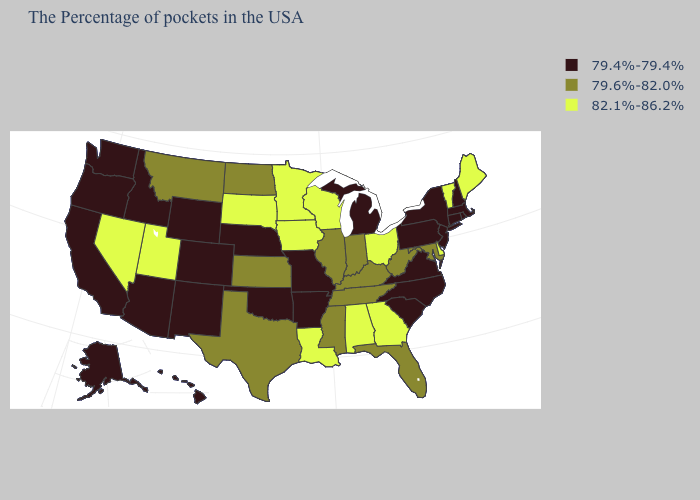What is the value of Delaware?
Short answer required. 82.1%-86.2%. What is the highest value in states that border New Jersey?
Quick response, please. 82.1%-86.2%. What is the value of Tennessee?
Give a very brief answer. 79.6%-82.0%. Name the states that have a value in the range 79.4%-79.4%?
Keep it brief. Massachusetts, Rhode Island, New Hampshire, Connecticut, New York, New Jersey, Pennsylvania, Virginia, North Carolina, South Carolina, Michigan, Missouri, Arkansas, Nebraska, Oklahoma, Wyoming, Colorado, New Mexico, Arizona, Idaho, California, Washington, Oregon, Alaska, Hawaii. Does Oklahoma have a lower value than New York?
Keep it brief. No. Which states have the lowest value in the MidWest?
Quick response, please. Michigan, Missouri, Nebraska. Name the states that have a value in the range 79.4%-79.4%?
Write a very short answer. Massachusetts, Rhode Island, New Hampshire, Connecticut, New York, New Jersey, Pennsylvania, Virginia, North Carolina, South Carolina, Michigan, Missouri, Arkansas, Nebraska, Oklahoma, Wyoming, Colorado, New Mexico, Arizona, Idaho, California, Washington, Oregon, Alaska, Hawaii. Among the states that border Louisiana , does Texas have the lowest value?
Answer briefly. No. Name the states that have a value in the range 82.1%-86.2%?
Keep it brief. Maine, Vermont, Delaware, Ohio, Georgia, Alabama, Wisconsin, Louisiana, Minnesota, Iowa, South Dakota, Utah, Nevada. Which states have the lowest value in the USA?
Concise answer only. Massachusetts, Rhode Island, New Hampshire, Connecticut, New York, New Jersey, Pennsylvania, Virginia, North Carolina, South Carolina, Michigan, Missouri, Arkansas, Nebraska, Oklahoma, Wyoming, Colorado, New Mexico, Arizona, Idaho, California, Washington, Oregon, Alaska, Hawaii. Name the states that have a value in the range 79.4%-79.4%?
Keep it brief. Massachusetts, Rhode Island, New Hampshire, Connecticut, New York, New Jersey, Pennsylvania, Virginia, North Carolina, South Carolina, Michigan, Missouri, Arkansas, Nebraska, Oklahoma, Wyoming, Colorado, New Mexico, Arizona, Idaho, California, Washington, Oregon, Alaska, Hawaii. Name the states that have a value in the range 82.1%-86.2%?
Give a very brief answer. Maine, Vermont, Delaware, Ohio, Georgia, Alabama, Wisconsin, Louisiana, Minnesota, Iowa, South Dakota, Utah, Nevada. Does the first symbol in the legend represent the smallest category?
Concise answer only. Yes. Name the states that have a value in the range 79.6%-82.0%?
Give a very brief answer. Maryland, West Virginia, Florida, Kentucky, Indiana, Tennessee, Illinois, Mississippi, Kansas, Texas, North Dakota, Montana. Does Tennessee have the lowest value in the USA?
Answer briefly. No. 